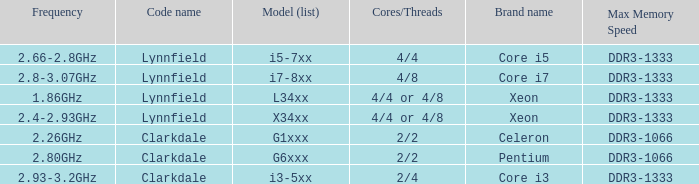List the number of cores for ddr3-1333 with frequencies between 2.66-2.8ghz. 4/4. 